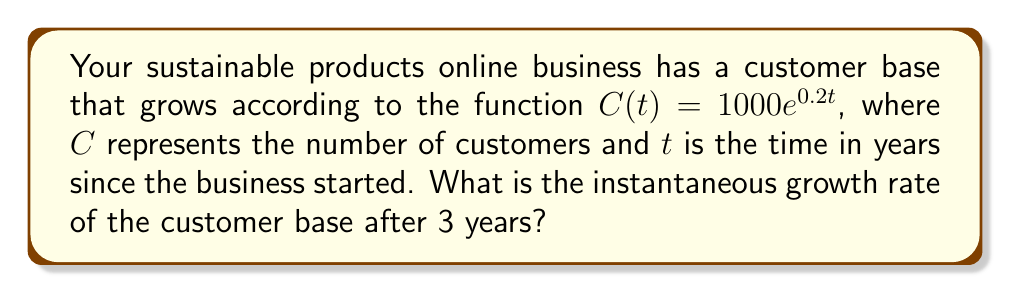Teach me how to tackle this problem. To find the instantaneous growth rate of the customer base after 3 years, we need to calculate the derivative of the given function and evaluate it at $t = 3$. Here's the step-by-step process:

1) The given function is $C(t) = 1000e^{0.2t}$

2) To find the derivative, we use the chain rule:
   $$\frac{dC}{dt} = 1000 \cdot \frac{d}{dt}(e^{0.2t})$$
   $$\frac{dC}{dt} = 1000 \cdot 0.2 \cdot e^{0.2t}$$
   $$\frac{dC}{dt} = 200e^{0.2t}$$

3) This derivative represents the instantaneous growth rate of the customer base at any time $t$.

4) To find the growth rate after 3 years, we evaluate the derivative at $t = 3$:
   $$\frac{dC}{dt}|_{t=3} = 200e^{0.2(3)}$$
   $$\frac{dC}{dt}|_{t=3} = 200e^{0.6}$$
   $$\frac{dC}{dt}|_{t=3} = 200 \cdot 1.8221 \approx 364.42$$

5) Therefore, after 3 years, the customer base is growing at a rate of approximately 364.42 customers per year.
Answer: 364.42 customers per year 